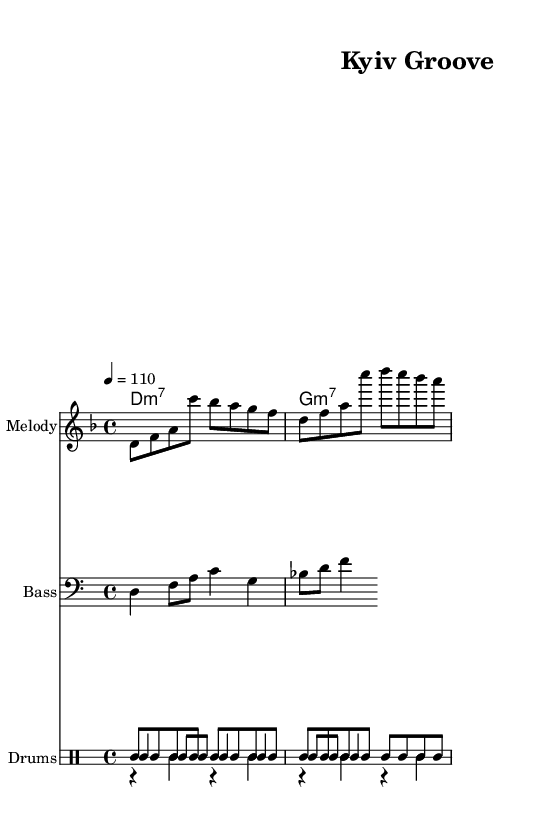What is the key signature of this music? The key signature is indicated by the number of sharps or flats at the beginning of the staff. Here, the presence of one flat indicates that the key is D minor.
Answer: D minor What is the time signature of this music? The time signature is written as a fraction at the beginning of the staff. Here, it shows 4/4, meaning there are four beats per measure and each beat is a quarter note.
Answer: 4/4 What is the tempo marking for this piece? The tempo marking is found at the beginning of the score with the note value and number. In this case, it states "4 = 110," indicating the speed of the piece in beats per minute.
Answer: 110 How many measures are in the melody? Counting the vertical lines that indicate the end of each measure, there are a total of 4 measures shown in the melody staff.
Answer: 4 What chord is played in the first measure? The chord indicated in the first measure of the chord names is D minor 7, shown by the notation "d1:m7."
Answer: D minor 7 What rhythmic pattern is primarily used in the drums? Observing the drum lines, the rhythmic pattern shows consistent emphasis on the bass drum, with a straightforward steady backbeat and hi-hat accompaniment.
Answer: Bass with snare What musical style does this piece represent? The incorporation of syncopated rhythms, the overall groove, and the instrumental setup suggest that this piece belongs to the funk genre.
Answer: Funk 